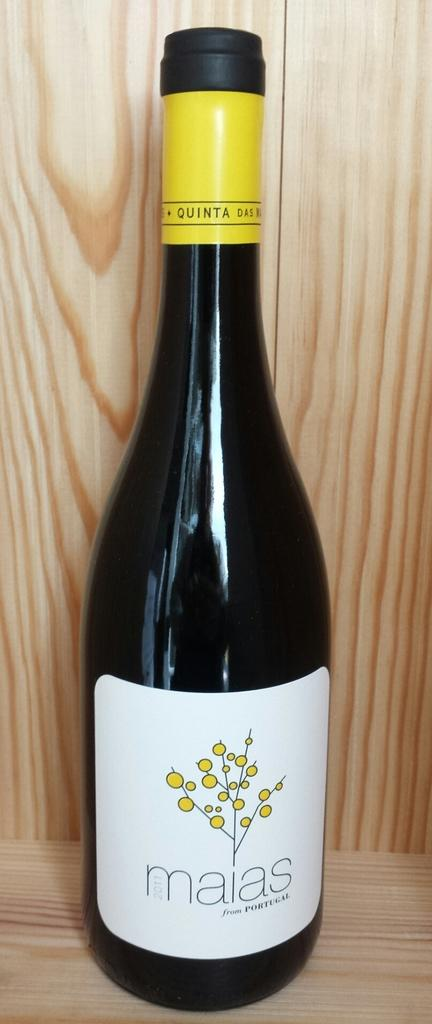<image>
Describe the image concisely. Black bottle with a white label that says the word "maias" on it. 